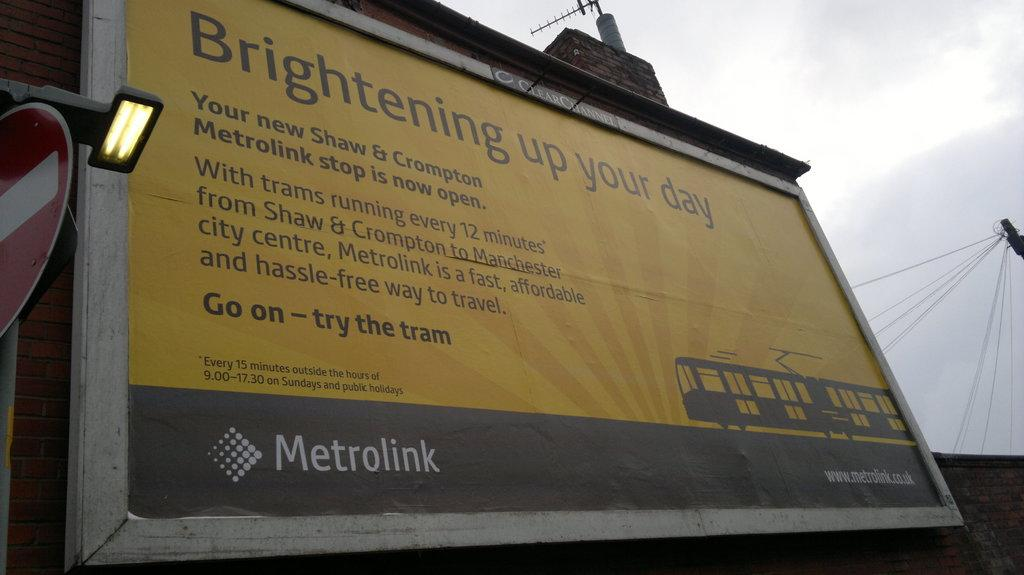<image>
Provide a brief description of the given image. An advertisement from Metrolink that is about brightening up your day. 